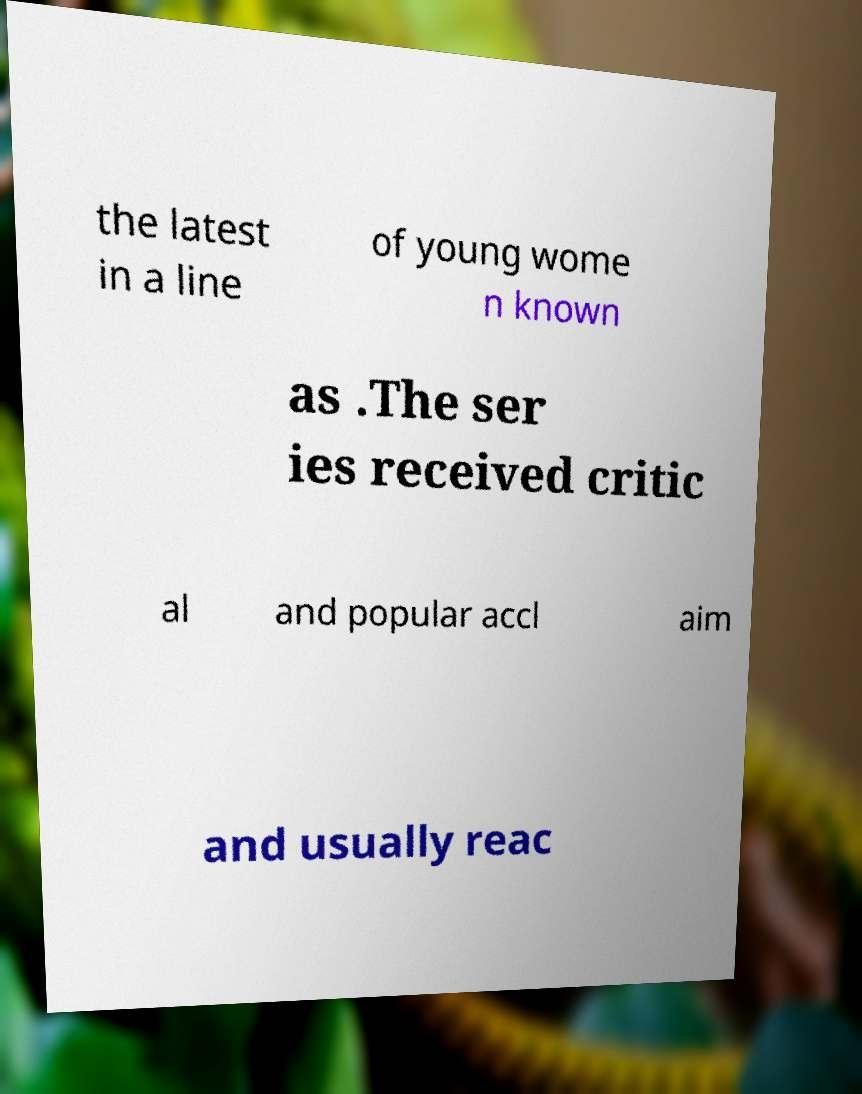There's text embedded in this image that I need extracted. Can you transcribe it verbatim? the latest in a line of young wome n known as .The ser ies received critic al and popular accl aim and usually reac 